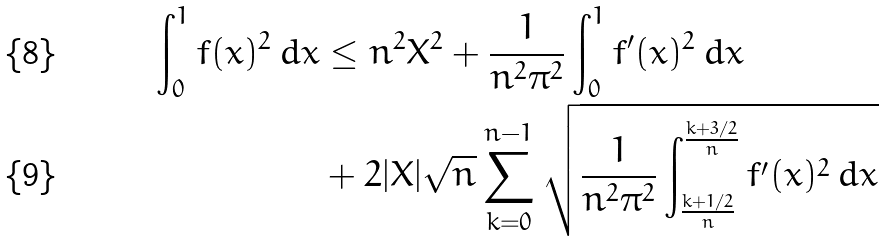<formula> <loc_0><loc_0><loc_500><loc_500>\int _ { 0 } ^ { 1 } f ( x ) ^ { 2 } \, d x & \leq n ^ { 2 } X ^ { 2 } + \frac { 1 } { n ^ { 2 } \pi ^ { 2 } } \int _ { 0 } ^ { 1 } f ^ { \prime } ( x ) ^ { 2 } \, d x \\ & + 2 | X | \sqrt { n } \sum _ { k = 0 } ^ { n - 1 } \sqrt { \frac { 1 } { n ^ { 2 } \pi ^ { 2 } } \int _ { \frac { k + 1 / 2 } { n } } ^ { \frac { k + 3 / 2 } { n } } f ^ { \prime } ( x ) ^ { 2 } \, d x }</formula> 